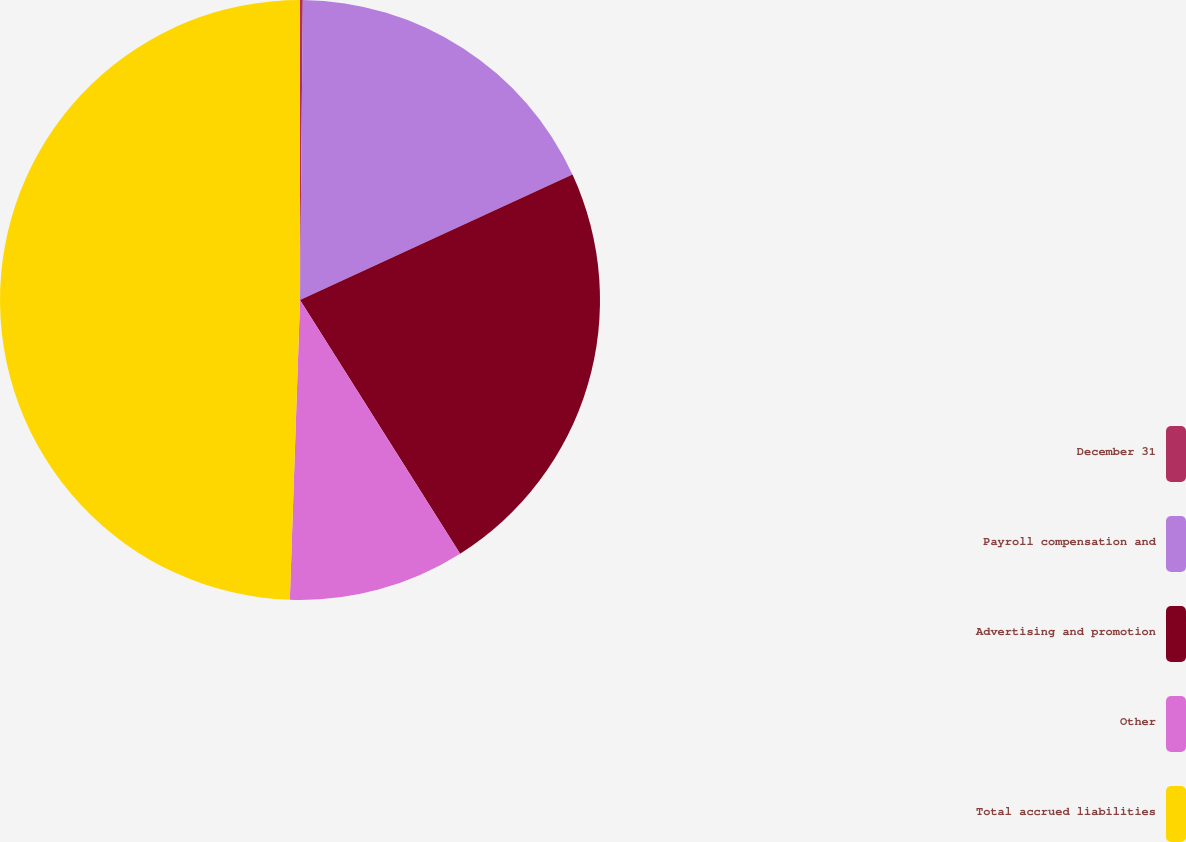Convert chart. <chart><loc_0><loc_0><loc_500><loc_500><pie_chart><fcel>December 31<fcel>Payroll compensation and<fcel>Advertising and promotion<fcel>Other<fcel>Total accrued liabilities<nl><fcel>0.15%<fcel>17.98%<fcel>22.91%<fcel>9.5%<fcel>49.46%<nl></chart> 